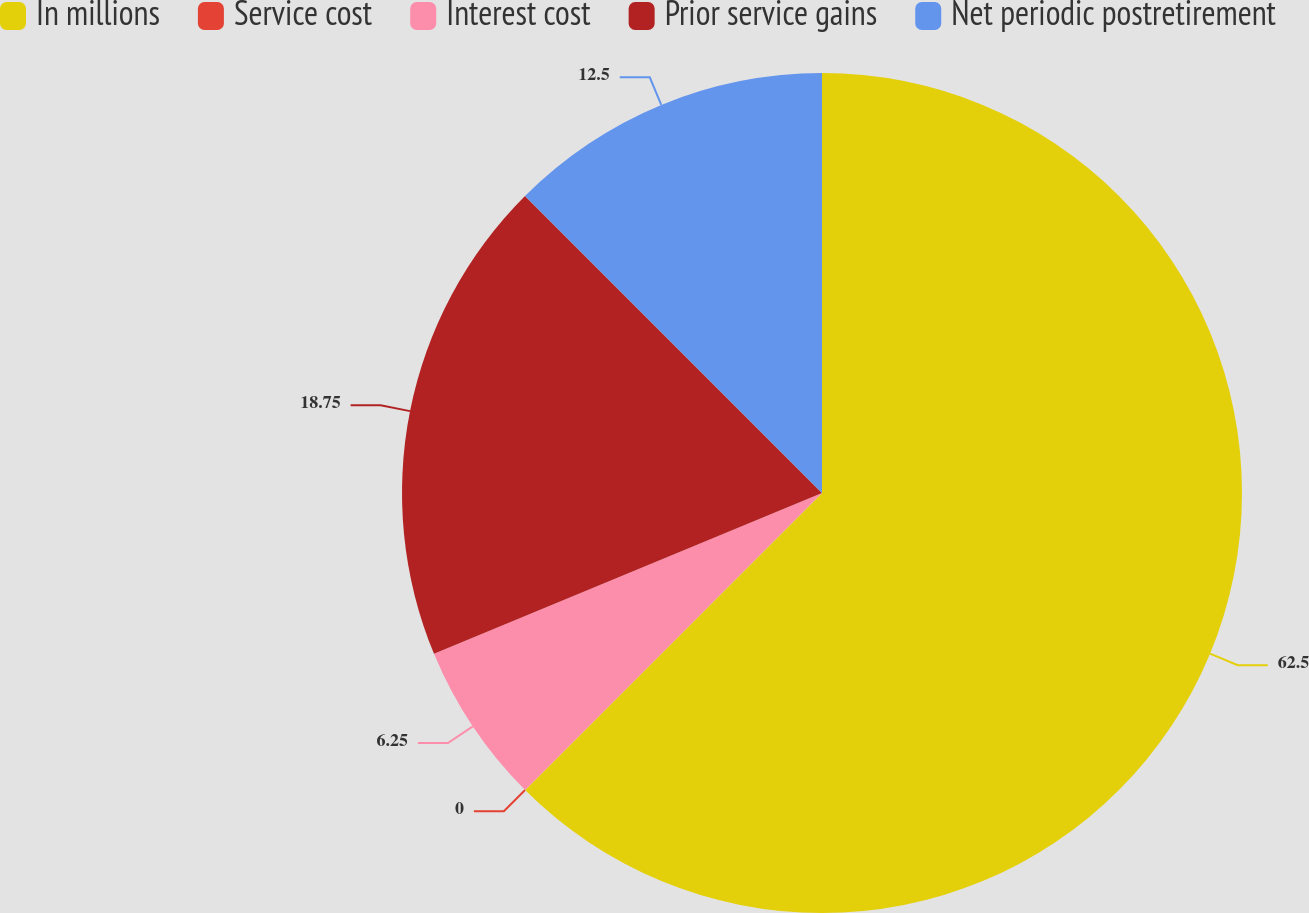Convert chart to OTSL. <chart><loc_0><loc_0><loc_500><loc_500><pie_chart><fcel>In millions<fcel>Service cost<fcel>Interest cost<fcel>Prior service gains<fcel>Net periodic postretirement<nl><fcel>62.49%<fcel>0.0%<fcel>6.25%<fcel>18.75%<fcel>12.5%<nl></chart> 